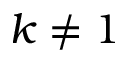<formula> <loc_0><loc_0><loc_500><loc_500>k \ne 1</formula> 